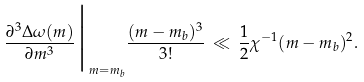Convert formula to latex. <formula><loc_0><loc_0><loc_500><loc_500>\frac { \partial ^ { 3 } \Delta \omega ( m ) } { \partial m ^ { 3 } } \Big | _ { m = m _ { b } } \frac { ( m - m _ { b } ) ^ { 3 } } { 3 ! } \, \ll \, \frac { 1 } { 2 } \chi ^ { - 1 } ( m - m _ { b } ) ^ { 2 } .</formula> 